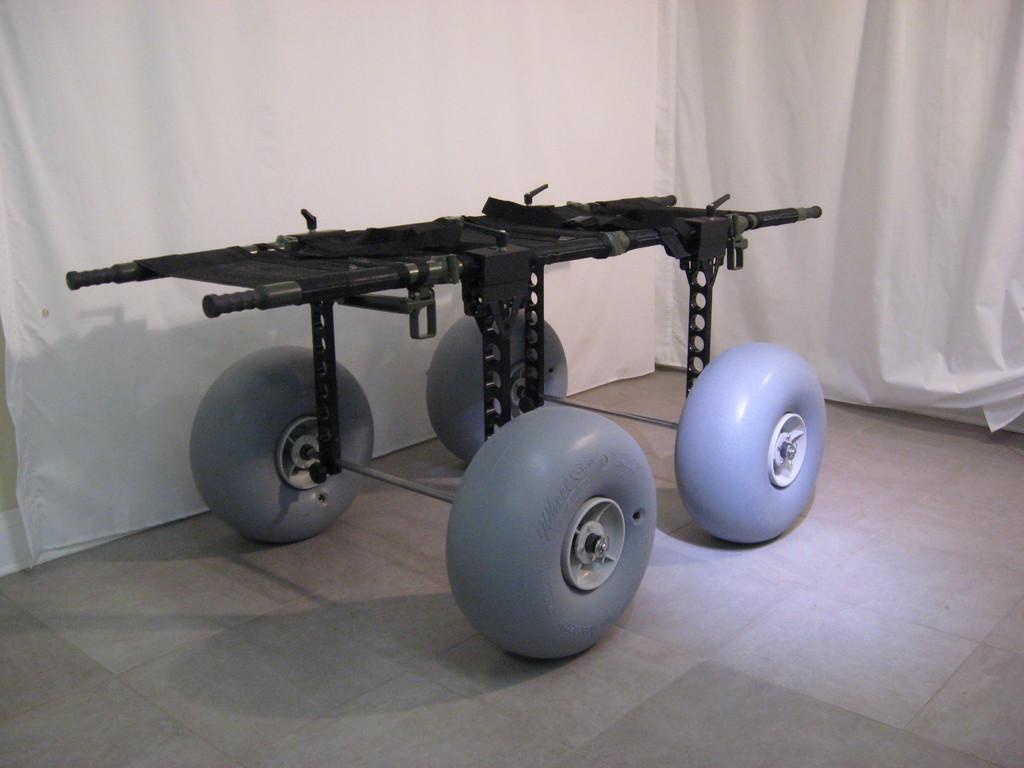How would you summarize this image in a sentence or two? In this image there is one rover robot in middle of this image and there are some white color curtains in the background. 